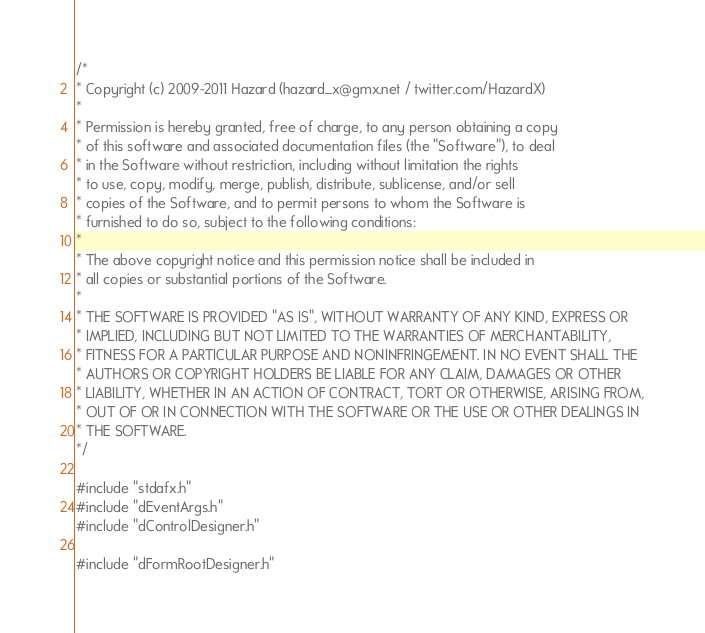Convert code to text. <code><loc_0><loc_0><loc_500><loc_500><_C++_>/*
* Copyright (c) 2009-2011 Hazard (hazard_x@gmx.net / twitter.com/HazardX)
* 
* Permission is hereby granted, free of charge, to any person obtaining a copy
* of this software and associated documentation files (the "Software"), to deal
* in the Software without restriction, including without limitation the rights
* to use, copy, modify, merge, publish, distribute, sublicense, and/or sell
* copies of the Software, and to permit persons to whom the Software is
* furnished to do so, subject to the following conditions:
* 
* The above copyright notice and this permission notice shall be included in
* all copies or substantial portions of the Software.
* 
* THE SOFTWARE IS PROVIDED "AS IS", WITHOUT WARRANTY OF ANY KIND, EXPRESS OR
* IMPLIED, INCLUDING BUT NOT LIMITED TO THE WARRANTIES OF MERCHANTABILITY,
* FITNESS FOR A PARTICULAR PURPOSE AND NONINFRINGEMENT. IN NO EVENT SHALL THE
* AUTHORS OR COPYRIGHT HOLDERS BE LIABLE FOR ANY CLAIM, DAMAGES OR OTHER
* LIABILITY, WHETHER IN AN ACTION OF CONTRACT, TORT OR OTHERWISE, ARISING FROM,
* OUT OF OR IN CONNECTION WITH THE SOFTWARE OR THE USE OR OTHER DEALINGS IN
* THE SOFTWARE.
*/

#include "stdafx.h"
#include "dEventArgs.h"
#include "dControlDesigner.h"

#include "dFormRootDesigner.h"</code> 